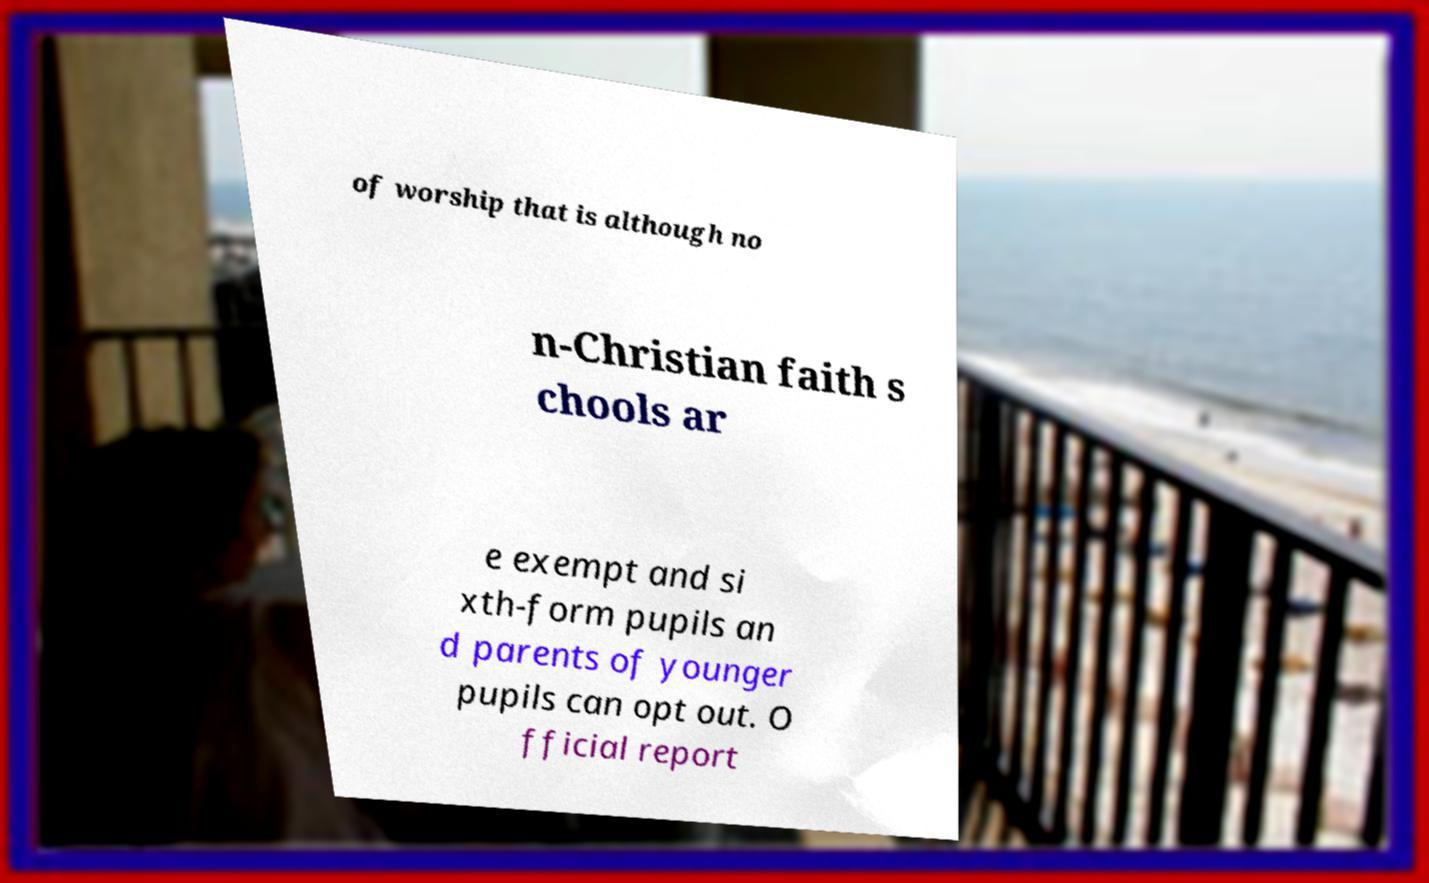I need the written content from this picture converted into text. Can you do that? of worship that is although no n-Christian faith s chools ar e exempt and si xth-form pupils an d parents of younger pupils can opt out. O fficial report 